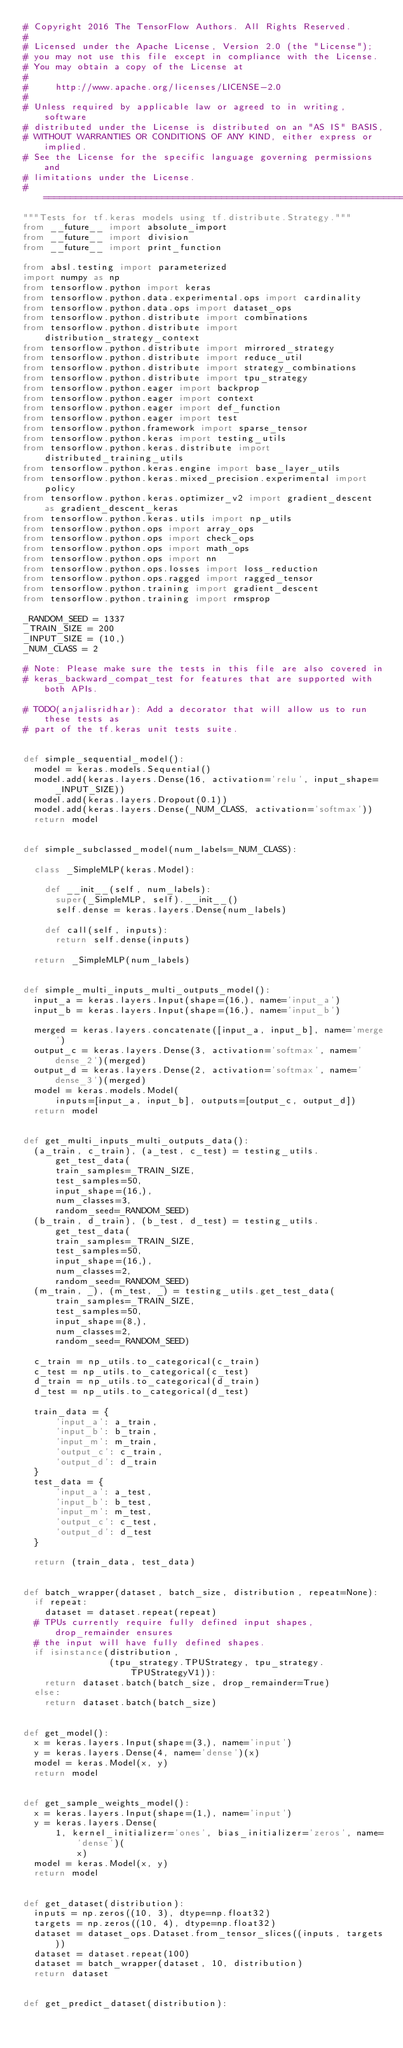Convert code to text. <code><loc_0><loc_0><loc_500><loc_500><_Python_># Copyright 2016 The TensorFlow Authors. All Rights Reserved.
#
# Licensed under the Apache License, Version 2.0 (the "License");
# you may not use this file except in compliance with the License.
# You may obtain a copy of the License at
#
#     http://www.apache.org/licenses/LICENSE-2.0
#
# Unless required by applicable law or agreed to in writing, software
# distributed under the License is distributed on an "AS IS" BASIS,
# WITHOUT WARRANTIES OR CONDITIONS OF ANY KIND, either express or implied.
# See the License for the specific language governing permissions and
# limitations under the License.
# ==============================================================================
"""Tests for tf.keras models using tf.distribute.Strategy."""
from __future__ import absolute_import
from __future__ import division
from __future__ import print_function

from absl.testing import parameterized
import numpy as np
from tensorflow.python import keras
from tensorflow.python.data.experimental.ops import cardinality
from tensorflow.python.data.ops import dataset_ops
from tensorflow.python.distribute import combinations
from tensorflow.python.distribute import distribution_strategy_context
from tensorflow.python.distribute import mirrored_strategy
from tensorflow.python.distribute import reduce_util
from tensorflow.python.distribute import strategy_combinations
from tensorflow.python.distribute import tpu_strategy
from tensorflow.python.eager import backprop
from tensorflow.python.eager import context
from tensorflow.python.eager import def_function
from tensorflow.python.eager import test
from tensorflow.python.framework import sparse_tensor
from tensorflow.python.keras import testing_utils
from tensorflow.python.keras.distribute import distributed_training_utils
from tensorflow.python.keras.engine import base_layer_utils
from tensorflow.python.keras.mixed_precision.experimental import policy
from tensorflow.python.keras.optimizer_v2 import gradient_descent as gradient_descent_keras
from tensorflow.python.keras.utils import np_utils
from tensorflow.python.ops import array_ops
from tensorflow.python.ops import check_ops
from tensorflow.python.ops import math_ops
from tensorflow.python.ops import nn
from tensorflow.python.ops.losses import loss_reduction
from tensorflow.python.ops.ragged import ragged_tensor
from tensorflow.python.training import gradient_descent
from tensorflow.python.training import rmsprop

_RANDOM_SEED = 1337
_TRAIN_SIZE = 200
_INPUT_SIZE = (10,)
_NUM_CLASS = 2

# Note: Please make sure the tests in this file are also covered in
# keras_backward_compat_test for features that are supported with both APIs.

# TODO(anjalisridhar): Add a decorator that will allow us to run these tests as
# part of the tf.keras unit tests suite.


def simple_sequential_model():
  model = keras.models.Sequential()
  model.add(keras.layers.Dense(16, activation='relu', input_shape=_INPUT_SIZE))
  model.add(keras.layers.Dropout(0.1))
  model.add(keras.layers.Dense(_NUM_CLASS, activation='softmax'))
  return model


def simple_subclassed_model(num_labels=_NUM_CLASS):

  class _SimpleMLP(keras.Model):

    def __init__(self, num_labels):
      super(_SimpleMLP, self).__init__()
      self.dense = keras.layers.Dense(num_labels)

    def call(self, inputs):
      return self.dense(inputs)

  return _SimpleMLP(num_labels)


def simple_multi_inputs_multi_outputs_model():
  input_a = keras.layers.Input(shape=(16,), name='input_a')
  input_b = keras.layers.Input(shape=(16,), name='input_b')

  merged = keras.layers.concatenate([input_a, input_b], name='merge')
  output_c = keras.layers.Dense(3, activation='softmax', name='dense_2')(merged)
  output_d = keras.layers.Dense(2, activation='softmax', name='dense_3')(merged)
  model = keras.models.Model(
      inputs=[input_a, input_b], outputs=[output_c, output_d])
  return model


def get_multi_inputs_multi_outputs_data():
  (a_train, c_train), (a_test, c_test) = testing_utils.get_test_data(
      train_samples=_TRAIN_SIZE,
      test_samples=50,
      input_shape=(16,),
      num_classes=3,
      random_seed=_RANDOM_SEED)
  (b_train, d_train), (b_test, d_test) = testing_utils.get_test_data(
      train_samples=_TRAIN_SIZE,
      test_samples=50,
      input_shape=(16,),
      num_classes=2,
      random_seed=_RANDOM_SEED)
  (m_train, _), (m_test, _) = testing_utils.get_test_data(
      train_samples=_TRAIN_SIZE,
      test_samples=50,
      input_shape=(8,),
      num_classes=2,
      random_seed=_RANDOM_SEED)

  c_train = np_utils.to_categorical(c_train)
  c_test = np_utils.to_categorical(c_test)
  d_train = np_utils.to_categorical(d_train)
  d_test = np_utils.to_categorical(d_test)

  train_data = {
      'input_a': a_train,
      'input_b': b_train,
      'input_m': m_train,
      'output_c': c_train,
      'output_d': d_train
  }
  test_data = {
      'input_a': a_test,
      'input_b': b_test,
      'input_m': m_test,
      'output_c': c_test,
      'output_d': d_test
  }

  return (train_data, test_data)


def batch_wrapper(dataset, batch_size, distribution, repeat=None):
  if repeat:
    dataset = dataset.repeat(repeat)
  # TPUs currently require fully defined input shapes, drop_remainder ensures
  # the input will have fully defined shapes.
  if isinstance(distribution,
                (tpu_strategy.TPUStrategy, tpu_strategy.TPUStrategyV1)):
    return dataset.batch(batch_size, drop_remainder=True)
  else:
    return dataset.batch(batch_size)


def get_model():
  x = keras.layers.Input(shape=(3,), name='input')
  y = keras.layers.Dense(4, name='dense')(x)
  model = keras.Model(x, y)
  return model


def get_sample_weights_model():
  x = keras.layers.Input(shape=(1,), name='input')
  y = keras.layers.Dense(
      1, kernel_initializer='ones', bias_initializer='zeros', name='dense')(
          x)
  model = keras.Model(x, y)
  return model


def get_dataset(distribution):
  inputs = np.zeros((10, 3), dtype=np.float32)
  targets = np.zeros((10, 4), dtype=np.float32)
  dataset = dataset_ops.Dataset.from_tensor_slices((inputs, targets))
  dataset = dataset.repeat(100)
  dataset = batch_wrapper(dataset, 10, distribution)
  return dataset


def get_predict_dataset(distribution):</code> 